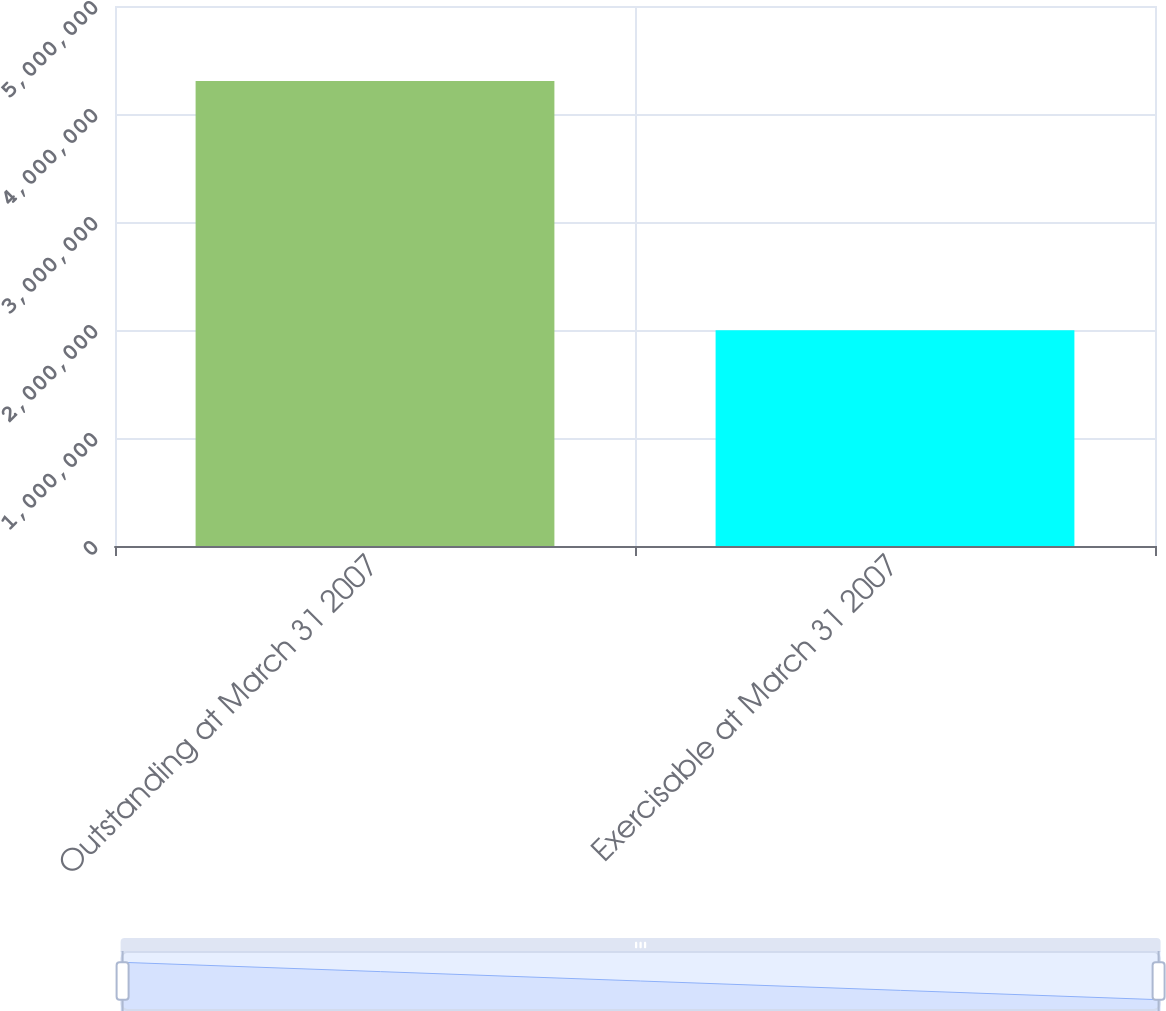Convert chart to OTSL. <chart><loc_0><loc_0><loc_500><loc_500><bar_chart><fcel>Outstanding at March 31 2007<fcel>Exercisable at March 31 2007<nl><fcel>4.30592e+06<fcel>1.99701e+06<nl></chart> 